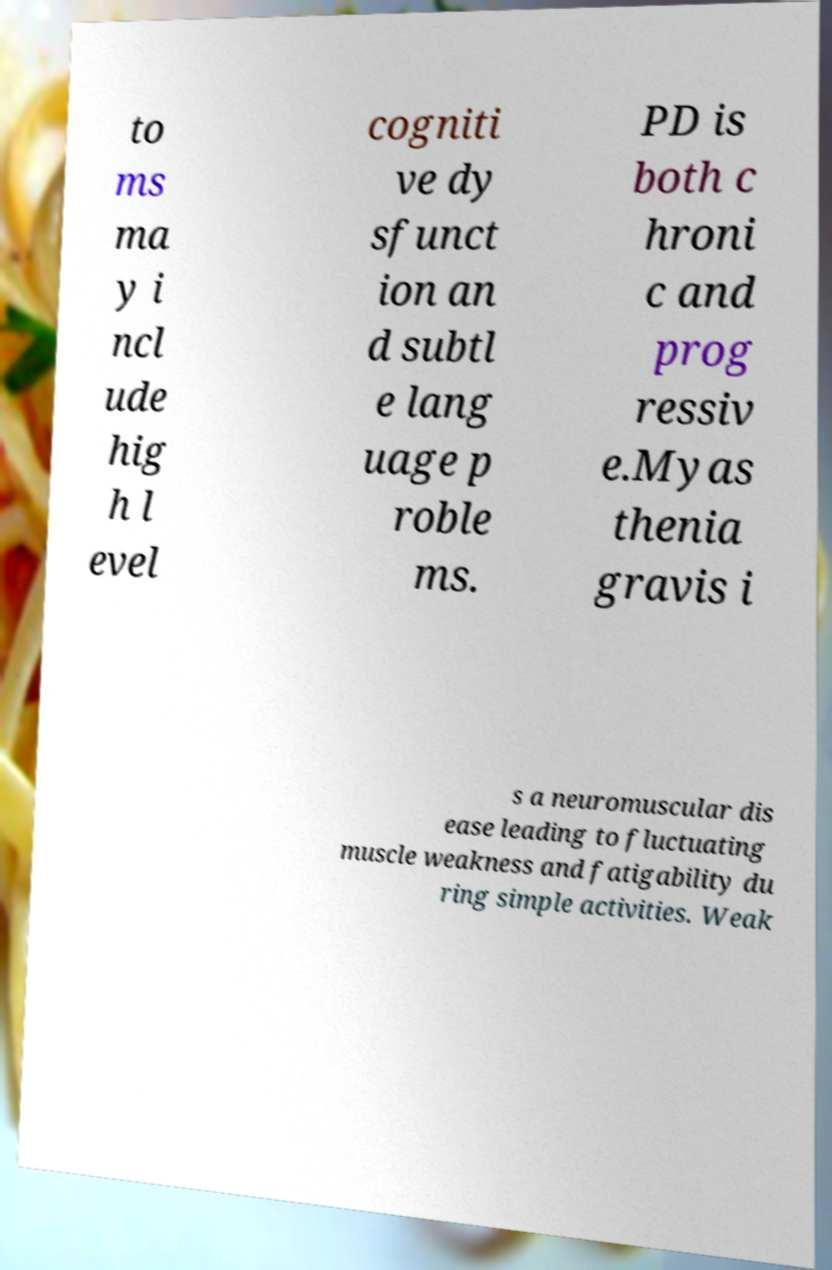Could you assist in decoding the text presented in this image and type it out clearly? to ms ma y i ncl ude hig h l evel cogniti ve dy sfunct ion an d subtl e lang uage p roble ms. PD is both c hroni c and prog ressiv e.Myas thenia gravis i s a neuromuscular dis ease leading to fluctuating muscle weakness and fatigability du ring simple activities. Weak 